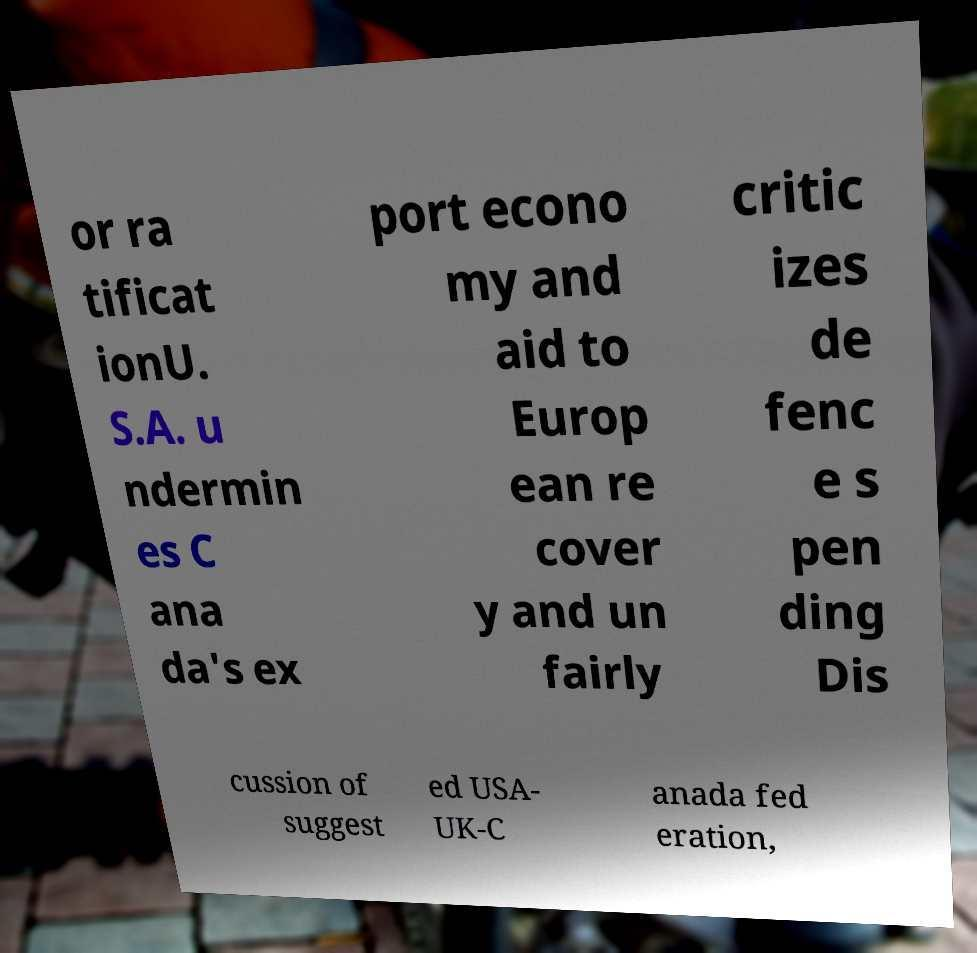For documentation purposes, I need the text within this image transcribed. Could you provide that? or ra tificat ionU. S.A. u ndermin es C ana da's ex port econo my and aid to Europ ean re cover y and un fairly critic izes de fenc e s pen ding Dis cussion of suggest ed USA- UK-C anada fed eration, 